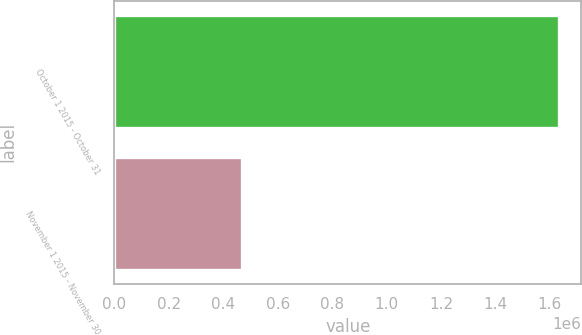Convert chart to OTSL. <chart><loc_0><loc_0><loc_500><loc_500><bar_chart><fcel>October 1 2015 - October 31<fcel>November 1 2015 - November 30<nl><fcel>1.63282e+06<fcel>470468<nl></chart> 